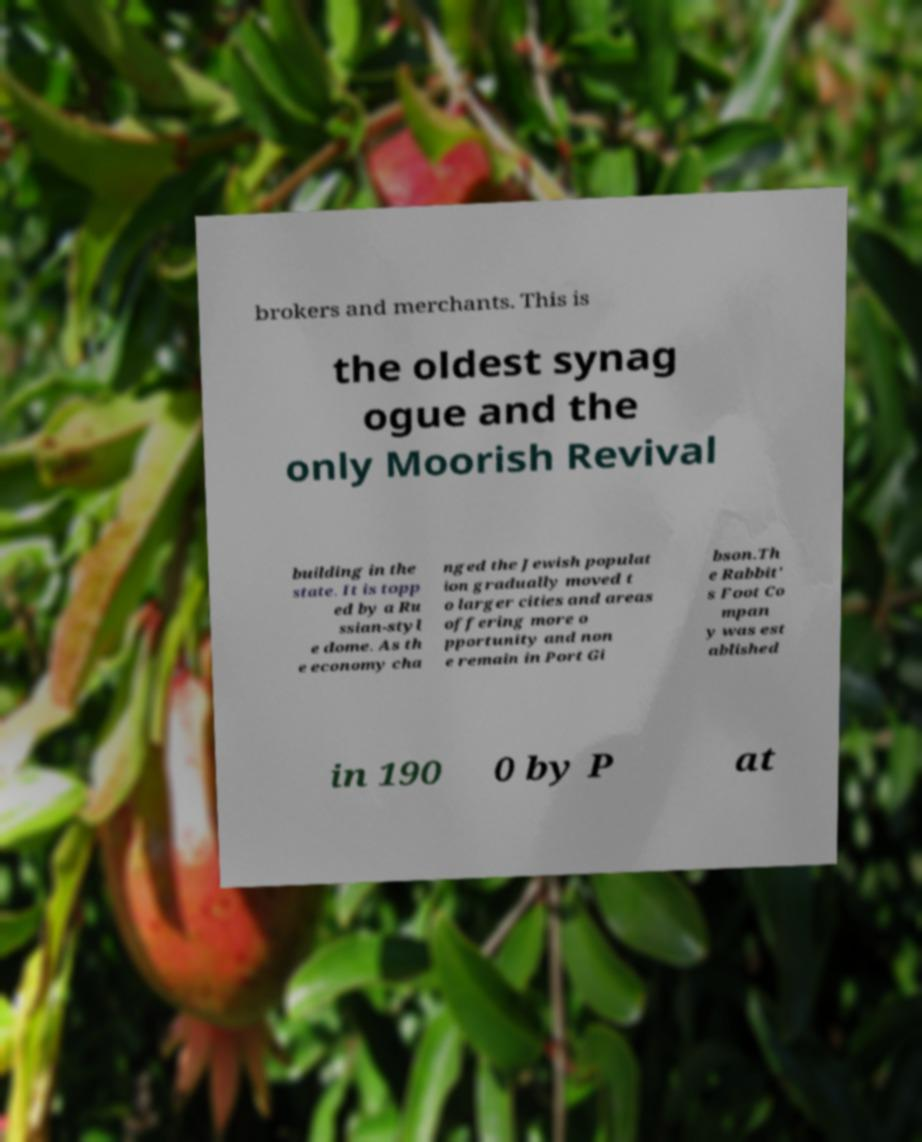There's text embedded in this image that I need extracted. Can you transcribe it verbatim? brokers and merchants. This is the oldest synag ogue and the only Moorish Revival building in the state. It is topp ed by a Ru ssian-styl e dome. As th e economy cha nged the Jewish populat ion gradually moved t o larger cities and areas offering more o pportunity and non e remain in Port Gi bson.Th e Rabbit' s Foot Co mpan y was est ablished in 190 0 by P at 